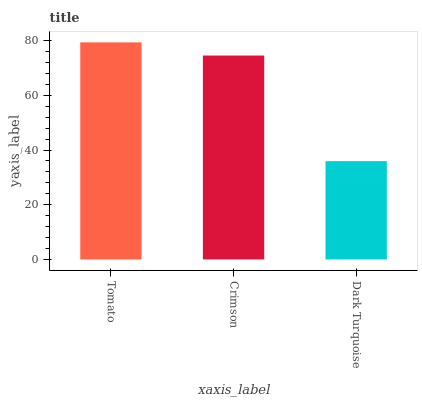Is Dark Turquoise the minimum?
Answer yes or no. Yes. Is Tomato the maximum?
Answer yes or no. Yes. Is Crimson the minimum?
Answer yes or no. No. Is Crimson the maximum?
Answer yes or no. No. Is Tomato greater than Crimson?
Answer yes or no. Yes. Is Crimson less than Tomato?
Answer yes or no. Yes. Is Crimson greater than Tomato?
Answer yes or no. No. Is Tomato less than Crimson?
Answer yes or no. No. Is Crimson the high median?
Answer yes or no. Yes. Is Crimson the low median?
Answer yes or no. Yes. Is Dark Turquoise the high median?
Answer yes or no. No. Is Tomato the low median?
Answer yes or no. No. 